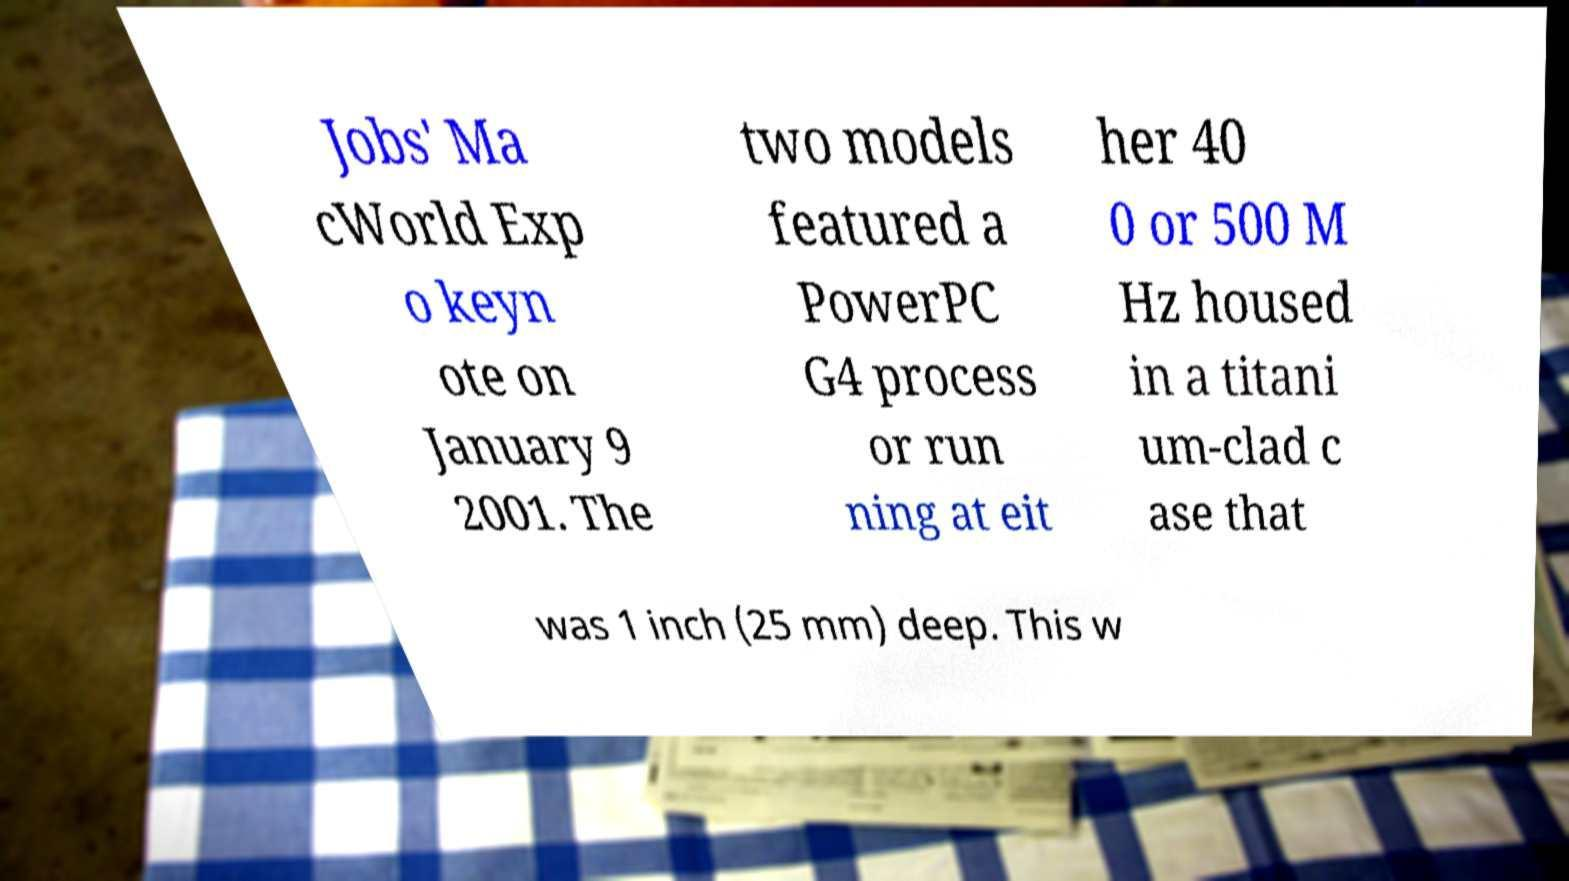Could you assist in decoding the text presented in this image and type it out clearly? Jobs' Ma cWorld Exp o keyn ote on January 9 2001. The two models featured a PowerPC G4 process or run ning at eit her 40 0 or 500 M Hz housed in a titani um-clad c ase that was 1 inch (25 mm) deep. This w 